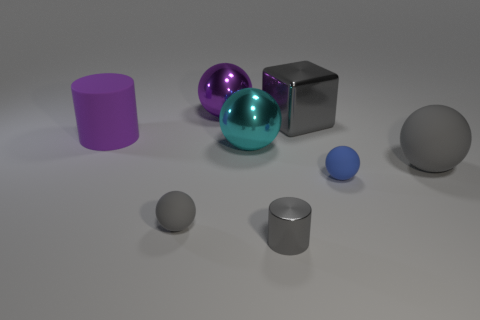Subtract all cyan spheres. How many spheres are left? 4 Subtract all small gray matte balls. How many balls are left? 4 Subtract all cyan balls. Subtract all brown blocks. How many balls are left? 4 Add 2 tiny yellow rubber cylinders. How many objects exist? 10 Subtract all blocks. How many objects are left? 7 Add 4 cyan metallic things. How many cyan metallic things are left? 5 Add 5 tiny gray balls. How many tiny gray balls exist? 6 Subtract 0 yellow spheres. How many objects are left? 8 Subtract all tiny yellow rubber objects. Subtract all big purple shiny things. How many objects are left? 7 